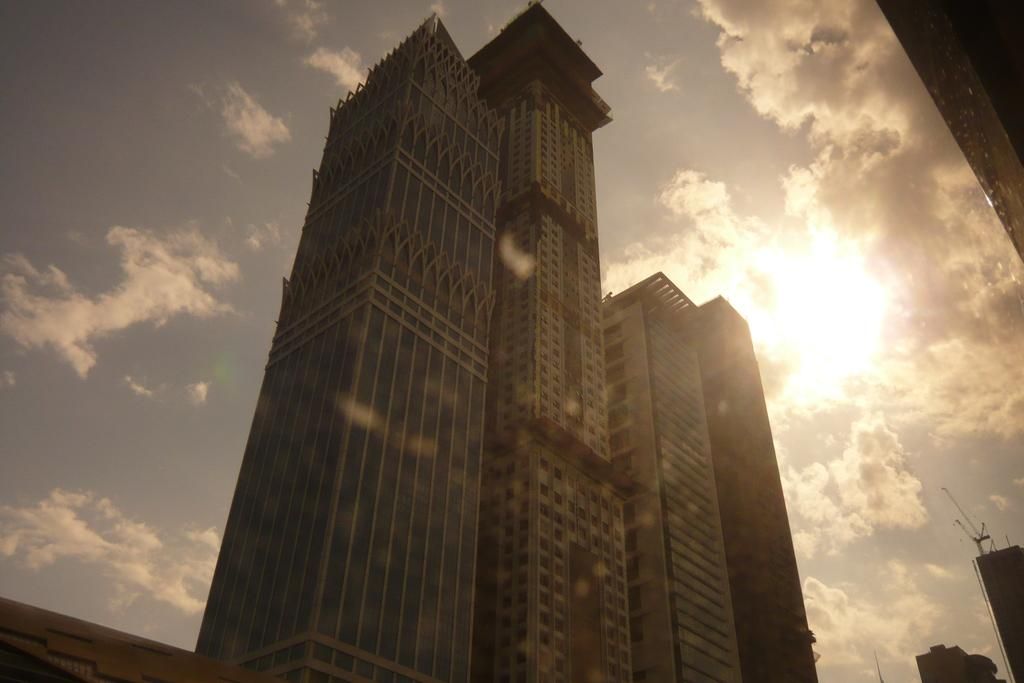What type of structures can be seen in the image? There are buildings in the image. What is visible in the background of the image? The sky is visible in the background of the image. What can be observed in the sky? Clouds are present in the sky. What type of liquid can be seen flowing down the mountain in the image? There is no mountain or liquid present in the image; it features buildings and a sky with clouds. 